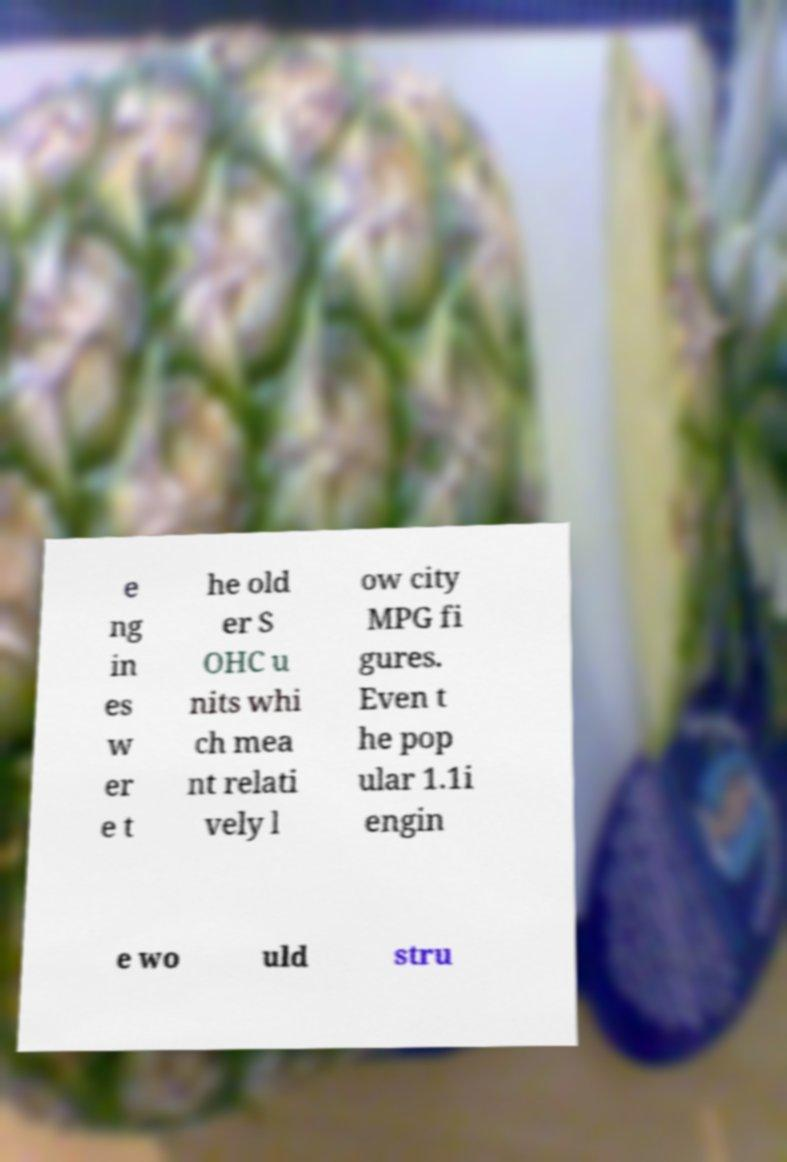Can you read and provide the text displayed in the image?This photo seems to have some interesting text. Can you extract and type it out for me? e ng in es w er e t he old er S OHC u nits whi ch mea nt relati vely l ow city MPG fi gures. Even t he pop ular 1.1i engin e wo uld stru 